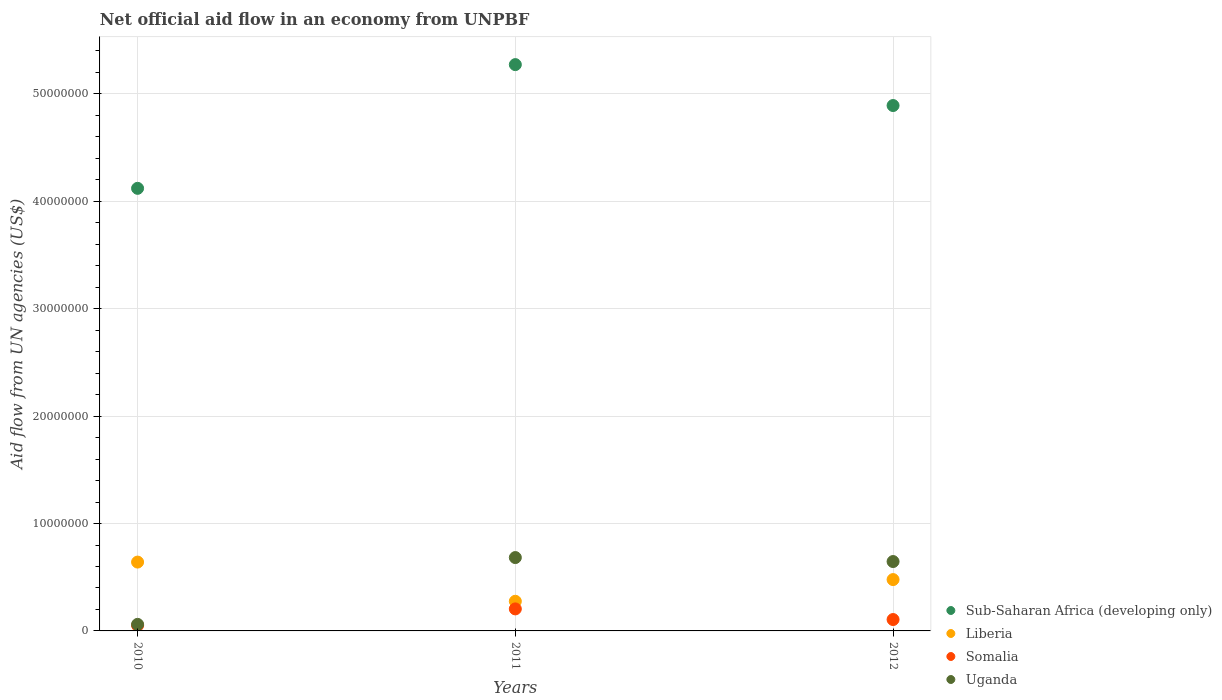How many different coloured dotlines are there?
Provide a succinct answer. 4. What is the net official aid flow in Somalia in 2012?
Your answer should be very brief. 1.06e+06. Across all years, what is the maximum net official aid flow in Sub-Saharan Africa (developing only)?
Ensure brevity in your answer.  5.27e+07. Across all years, what is the minimum net official aid flow in Liberia?
Offer a terse response. 2.76e+06. In which year was the net official aid flow in Somalia maximum?
Your answer should be very brief. 2011. What is the total net official aid flow in Uganda in the graph?
Provide a short and direct response. 1.39e+07. What is the difference between the net official aid flow in Liberia in 2010 and that in 2011?
Provide a short and direct response. 3.65e+06. What is the difference between the net official aid flow in Uganda in 2010 and the net official aid flow in Liberia in 2012?
Offer a terse response. -4.17e+06. What is the average net official aid flow in Somalia per year?
Your answer should be very brief. 1.21e+06. In the year 2012, what is the difference between the net official aid flow in Somalia and net official aid flow in Liberia?
Ensure brevity in your answer.  -3.72e+06. In how many years, is the net official aid flow in Somalia greater than 34000000 US$?
Your answer should be compact. 0. What is the ratio of the net official aid flow in Liberia in 2011 to that in 2012?
Provide a succinct answer. 0.58. Is the difference between the net official aid flow in Somalia in 2010 and 2012 greater than the difference between the net official aid flow in Liberia in 2010 and 2012?
Offer a terse response. No. What is the difference between the highest and the second highest net official aid flow in Liberia?
Your answer should be very brief. 1.63e+06. What is the difference between the highest and the lowest net official aid flow in Liberia?
Your answer should be compact. 3.65e+06. In how many years, is the net official aid flow in Uganda greater than the average net official aid flow in Uganda taken over all years?
Your answer should be very brief. 2. Is the sum of the net official aid flow in Liberia in 2010 and 2012 greater than the maximum net official aid flow in Uganda across all years?
Your response must be concise. Yes. Is it the case that in every year, the sum of the net official aid flow in Uganda and net official aid flow in Somalia  is greater than the sum of net official aid flow in Sub-Saharan Africa (developing only) and net official aid flow in Liberia?
Give a very brief answer. No. Is it the case that in every year, the sum of the net official aid flow in Uganda and net official aid flow in Sub-Saharan Africa (developing only)  is greater than the net official aid flow in Liberia?
Keep it short and to the point. Yes. Is the net official aid flow in Sub-Saharan Africa (developing only) strictly greater than the net official aid flow in Uganda over the years?
Your response must be concise. Yes. Is the net official aid flow in Liberia strictly less than the net official aid flow in Uganda over the years?
Your answer should be compact. No. How many dotlines are there?
Offer a terse response. 4. How many years are there in the graph?
Your answer should be very brief. 3. Are the values on the major ticks of Y-axis written in scientific E-notation?
Provide a succinct answer. No. Does the graph contain any zero values?
Provide a short and direct response. No. Where does the legend appear in the graph?
Your answer should be compact. Bottom right. What is the title of the graph?
Give a very brief answer. Net official aid flow in an economy from UNPBF. Does "Afghanistan" appear as one of the legend labels in the graph?
Your answer should be very brief. No. What is the label or title of the Y-axis?
Offer a very short reply. Aid flow from UN agencies (US$). What is the Aid flow from UN agencies (US$) in Sub-Saharan Africa (developing only) in 2010?
Your response must be concise. 4.12e+07. What is the Aid flow from UN agencies (US$) in Liberia in 2010?
Give a very brief answer. 6.41e+06. What is the Aid flow from UN agencies (US$) of Somalia in 2010?
Make the answer very short. 5.10e+05. What is the Aid flow from UN agencies (US$) in Uganda in 2010?
Your answer should be very brief. 6.10e+05. What is the Aid flow from UN agencies (US$) in Sub-Saharan Africa (developing only) in 2011?
Your response must be concise. 5.27e+07. What is the Aid flow from UN agencies (US$) in Liberia in 2011?
Ensure brevity in your answer.  2.76e+06. What is the Aid flow from UN agencies (US$) in Somalia in 2011?
Offer a terse response. 2.05e+06. What is the Aid flow from UN agencies (US$) of Uganda in 2011?
Make the answer very short. 6.83e+06. What is the Aid flow from UN agencies (US$) of Sub-Saharan Africa (developing only) in 2012?
Make the answer very short. 4.89e+07. What is the Aid flow from UN agencies (US$) in Liberia in 2012?
Your answer should be compact. 4.78e+06. What is the Aid flow from UN agencies (US$) in Somalia in 2012?
Offer a very short reply. 1.06e+06. What is the Aid flow from UN agencies (US$) of Uganda in 2012?
Provide a succinct answer. 6.46e+06. Across all years, what is the maximum Aid flow from UN agencies (US$) of Sub-Saharan Africa (developing only)?
Provide a short and direct response. 5.27e+07. Across all years, what is the maximum Aid flow from UN agencies (US$) of Liberia?
Provide a short and direct response. 6.41e+06. Across all years, what is the maximum Aid flow from UN agencies (US$) in Somalia?
Your answer should be compact. 2.05e+06. Across all years, what is the maximum Aid flow from UN agencies (US$) in Uganda?
Your answer should be compact. 6.83e+06. Across all years, what is the minimum Aid flow from UN agencies (US$) in Sub-Saharan Africa (developing only)?
Your response must be concise. 4.12e+07. Across all years, what is the minimum Aid flow from UN agencies (US$) of Liberia?
Your answer should be very brief. 2.76e+06. Across all years, what is the minimum Aid flow from UN agencies (US$) of Somalia?
Your response must be concise. 5.10e+05. What is the total Aid flow from UN agencies (US$) in Sub-Saharan Africa (developing only) in the graph?
Make the answer very short. 1.43e+08. What is the total Aid flow from UN agencies (US$) of Liberia in the graph?
Provide a short and direct response. 1.40e+07. What is the total Aid flow from UN agencies (US$) of Somalia in the graph?
Keep it short and to the point. 3.62e+06. What is the total Aid flow from UN agencies (US$) of Uganda in the graph?
Make the answer very short. 1.39e+07. What is the difference between the Aid flow from UN agencies (US$) in Sub-Saharan Africa (developing only) in 2010 and that in 2011?
Offer a very short reply. -1.15e+07. What is the difference between the Aid flow from UN agencies (US$) of Liberia in 2010 and that in 2011?
Your answer should be very brief. 3.65e+06. What is the difference between the Aid flow from UN agencies (US$) in Somalia in 2010 and that in 2011?
Your answer should be very brief. -1.54e+06. What is the difference between the Aid flow from UN agencies (US$) of Uganda in 2010 and that in 2011?
Make the answer very short. -6.22e+06. What is the difference between the Aid flow from UN agencies (US$) of Sub-Saharan Africa (developing only) in 2010 and that in 2012?
Offer a very short reply. -7.71e+06. What is the difference between the Aid flow from UN agencies (US$) of Liberia in 2010 and that in 2012?
Your answer should be compact. 1.63e+06. What is the difference between the Aid flow from UN agencies (US$) in Somalia in 2010 and that in 2012?
Your answer should be very brief. -5.50e+05. What is the difference between the Aid flow from UN agencies (US$) in Uganda in 2010 and that in 2012?
Make the answer very short. -5.85e+06. What is the difference between the Aid flow from UN agencies (US$) in Sub-Saharan Africa (developing only) in 2011 and that in 2012?
Ensure brevity in your answer.  3.81e+06. What is the difference between the Aid flow from UN agencies (US$) of Liberia in 2011 and that in 2012?
Your answer should be very brief. -2.02e+06. What is the difference between the Aid flow from UN agencies (US$) of Somalia in 2011 and that in 2012?
Provide a succinct answer. 9.90e+05. What is the difference between the Aid flow from UN agencies (US$) in Sub-Saharan Africa (developing only) in 2010 and the Aid flow from UN agencies (US$) in Liberia in 2011?
Make the answer very short. 3.84e+07. What is the difference between the Aid flow from UN agencies (US$) in Sub-Saharan Africa (developing only) in 2010 and the Aid flow from UN agencies (US$) in Somalia in 2011?
Ensure brevity in your answer.  3.92e+07. What is the difference between the Aid flow from UN agencies (US$) in Sub-Saharan Africa (developing only) in 2010 and the Aid flow from UN agencies (US$) in Uganda in 2011?
Provide a short and direct response. 3.44e+07. What is the difference between the Aid flow from UN agencies (US$) in Liberia in 2010 and the Aid flow from UN agencies (US$) in Somalia in 2011?
Your response must be concise. 4.36e+06. What is the difference between the Aid flow from UN agencies (US$) of Liberia in 2010 and the Aid flow from UN agencies (US$) of Uganda in 2011?
Your response must be concise. -4.20e+05. What is the difference between the Aid flow from UN agencies (US$) in Somalia in 2010 and the Aid flow from UN agencies (US$) in Uganda in 2011?
Provide a short and direct response. -6.32e+06. What is the difference between the Aid flow from UN agencies (US$) in Sub-Saharan Africa (developing only) in 2010 and the Aid flow from UN agencies (US$) in Liberia in 2012?
Offer a terse response. 3.64e+07. What is the difference between the Aid flow from UN agencies (US$) of Sub-Saharan Africa (developing only) in 2010 and the Aid flow from UN agencies (US$) of Somalia in 2012?
Keep it short and to the point. 4.02e+07. What is the difference between the Aid flow from UN agencies (US$) of Sub-Saharan Africa (developing only) in 2010 and the Aid flow from UN agencies (US$) of Uganda in 2012?
Your response must be concise. 3.48e+07. What is the difference between the Aid flow from UN agencies (US$) in Liberia in 2010 and the Aid flow from UN agencies (US$) in Somalia in 2012?
Provide a succinct answer. 5.35e+06. What is the difference between the Aid flow from UN agencies (US$) of Somalia in 2010 and the Aid flow from UN agencies (US$) of Uganda in 2012?
Your answer should be compact. -5.95e+06. What is the difference between the Aid flow from UN agencies (US$) of Sub-Saharan Africa (developing only) in 2011 and the Aid flow from UN agencies (US$) of Liberia in 2012?
Your answer should be very brief. 4.80e+07. What is the difference between the Aid flow from UN agencies (US$) of Sub-Saharan Africa (developing only) in 2011 and the Aid flow from UN agencies (US$) of Somalia in 2012?
Your response must be concise. 5.17e+07. What is the difference between the Aid flow from UN agencies (US$) of Sub-Saharan Africa (developing only) in 2011 and the Aid flow from UN agencies (US$) of Uganda in 2012?
Offer a terse response. 4.63e+07. What is the difference between the Aid flow from UN agencies (US$) of Liberia in 2011 and the Aid flow from UN agencies (US$) of Somalia in 2012?
Your response must be concise. 1.70e+06. What is the difference between the Aid flow from UN agencies (US$) of Liberia in 2011 and the Aid flow from UN agencies (US$) of Uganda in 2012?
Your answer should be compact. -3.70e+06. What is the difference between the Aid flow from UN agencies (US$) in Somalia in 2011 and the Aid flow from UN agencies (US$) in Uganda in 2012?
Ensure brevity in your answer.  -4.41e+06. What is the average Aid flow from UN agencies (US$) in Sub-Saharan Africa (developing only) per year?
Provide a succinct answer. 4.76e+07. What is the average Aid flow from UN agencies (US$) in Liberia per year?
Make the answer very short. 4.65e+06. What is the average Aid flow from UN agencies (US$) of Somalia per year?
Keep it short and to the point. 1.21e+06. What is the average Aid flow from UN agencies (US$) in Uganda per year?
Offer a very short reply. 4.63e+06. In the year 2010, what is the difference between the Aid flow from UN agencies (US$) in Sub-Saharan Africa (developing only) and Aid flow from UN agencies (US$) in Liberia?
Offer a very short reply. 3.48e+07. In the year 2010, what is the difference between the Aid flow from UN agencies (US$) of Sub-Saharan Africa (developing only) and Aid flow from UN agencies (US$) of Somalia?
Provide a succinct answer. 4.07e+07. In the year 2010, what is the difference between the Aid flow from UN agencies (US$) in Sub-Saharan Africa (developing only) and Aid flow from UN agencies (US$) in Uganda?
Your answer should be very brief. 4.06e+07. In the year 2010, what is the difference between the Aid flow from UN agencies (US$) in Liberia and Aid flow from UN agencies (US$) in Somalia?
Offer a terse response. 5.90e+06. In the year 2010, what is the difference between the Aid flow from UN agencies (US$) of Liberia and Aid flow from UN agencies (US$) of Uganda?
Your response must be concise. 5.80e+06. In the year 2011, what is the difference between the Aid flow from UN agencies (US$) in Sub-Saharan Africa (developing only) and Aid flow from UN agencies (US$) in Liberia?
Give a very brief answer. 5.00e+07. In the year 2011, what is the difference between the Aid flow from UN agencies (US$) of Sub-Saharan Africa (developing only) and Aid flow from UN agencies (US$) of Somalia?
Give a very brief answer. 5.07e+07. In the year 2011, what is the difference between the Aid flow from UN agencies (US$) in Sub-Saharan Africa (developing only) and Aid flow from UN agencies (US$) in Uganda?
Your response must be concise. 4.59e+07. In the year 2011, what is the difference between the Aid flow from UN agencies (US$) of Liberia and Aid flow from UN agencies (US$) of Somalia?
Your response must be concise. 7.10e+05. In the year 2011, what is the difference between the Aid flow from UN agencies (US$) of Liberia and Aid flow from UN agencies (US$) of Uganda?
Provide a succinct answer. -4.07e+06. In the year 2011, what is the difference between the Aid flow from UN agencies (US$) in Somalia and Aid flow from UN agencies (US$) in Uganda?
Keep it short and to the point. -4.78e+06. In the year 2012, what is the difference between the Aid flow from UN agencies (US$) of Sub-Saharan Africa (developing only) and Aid flow from UN agencies (US$) of Liberia?
Keep it short and to the point. 4.41e+07. In the year 2012, what is the difference between the Aid flow from UN agencies (US$) in Sub-Saharan Africa (developing only) and Aid flow from UN agencies (US$) in Somalia?
Your answer should be very brief. 4.79e+07. In the year 2012, what is the difference between the Aid flow from UN agencies (US$) of Sub-Saharan Africa (developing only) and Aid flow from UN agencies (US$) of Uganda?
Ensure brevity in your answer.  4.25e+07. In the year 2012, what is the difference between the Aid flow from UN agencies (US$) in Liberia and Aid flow from UN agencies (US$) in Somalia?
Offer a terse response. 3.72e+06. In the year 2012, what is the difference between the Aid flow from UN agencies (US$) of Liberia and Aid flow from UN agencies (US$) of Uganda?
Provide a short and direct response. -1.68e+06. In the year 2012, what is the difference between the Aid flow from UN agencies (US$) in Somalia and Aid flow from UN agencies (US$) in Uganda?
Give a very brief answer. -5.40e+06. What is the ratio of the Aid flow from UN agencies (US$) in Sub-Saharan Africa (developing only) in 2010 to that in 2011?
Make the answer very short. 0.78. What is the ratio of the Aid flow from UN agencies (US$) in Liberia in 2010 to that in 2011?
Provide a succinct answer. 2.32. What is the ratio of the Aid flow from UN agencies (US$) in Somalia in 2010 to that in 2011?
Ensure brevity in your answer.  0.25. What is the ratio of the Aid flow from UN agencies (US$) in Uganda in 2010 to that in 2011?
Provide a short and direct response. 0.09. What is the ratio of the Aid flow from UN agencies (US$) of Sub-Saharan Africa (developing only) in 2010 to that in 2012?
Offer a terse response. 0.84. What is the ratio of the Aid flow from UN agencies (US$) of Liberia in 2010 to that in 2012?
Your answer should be compact. 1.34. What is the ratio of the Aid flow from UN agencies (US$) in Somalia in 2010 to that in 2012?
Ensure brevity in your answer.  0.48. What is the ratio of the Aid flow from UN agencies (US$) in Uganda in 2010 to that in 2012?
Ensure brevity in your answer.  0.09. What is the ratio of the Aid flow from UN agencies (US$) of Sub-Saharan Africa (developing only) in 2011 to that in 2012?
Offer a terse response. 1.08. What is the ratio of the Aid flow from UN agencies (US$) of Liberia in 2011 to that in 2012?
Ensure brevity in your answer.  0.58. What is the ratio of the Aid flow from UN agencies (US$) of Somalia in 2011 to that in 2012?
Your answer should be compact. 1.93. What is the ratio of the Aid flow from UN agencies (US$) in Uganda in 2011 to that in 2012?
Your answer should be compact. 1.06. What is the difference between the highest and the second highest Aid flow from UN agencies (US$) of Sub-Saharan Africa (developing only)?
Your answer should be very brief. 3.81e+06. What is the difference between the highest and the second highest Aid flow from UN agencies (US$) in Liberia?
Offer a very short reply. 1.63e+06. What is the difference between the highest and the second highest Aid flow from UN agencies (US$) of Somalia?
Offer a terse response. 9.90e+05. What is the difference between the highest and the second highest Aid flow from UN agencies (US$) of Uganda?
Ensure brevity in your answer.  3.70e+05. What is the difference between the highest and the lowest Aid flow from UN agencies (US$) of Sub-Saharan Africa (developing only)?
Your answer should be very brief. 1.15e+07. What is the difference between the highest and the lowest Aid flow from UN agencies (US$) of Liberia?
Keep it short and to the point. 3.65e+06. What is the difference between the highest and the lowest Aid flow from UN agencies (US$) of Somalia?
Give a very brief answer. 1.54e+06. What is the difference between the highest and the lowest Aid flow from UN agencies (US$) of Uganda?
Provide a short and direct response. 6.22e+06. 